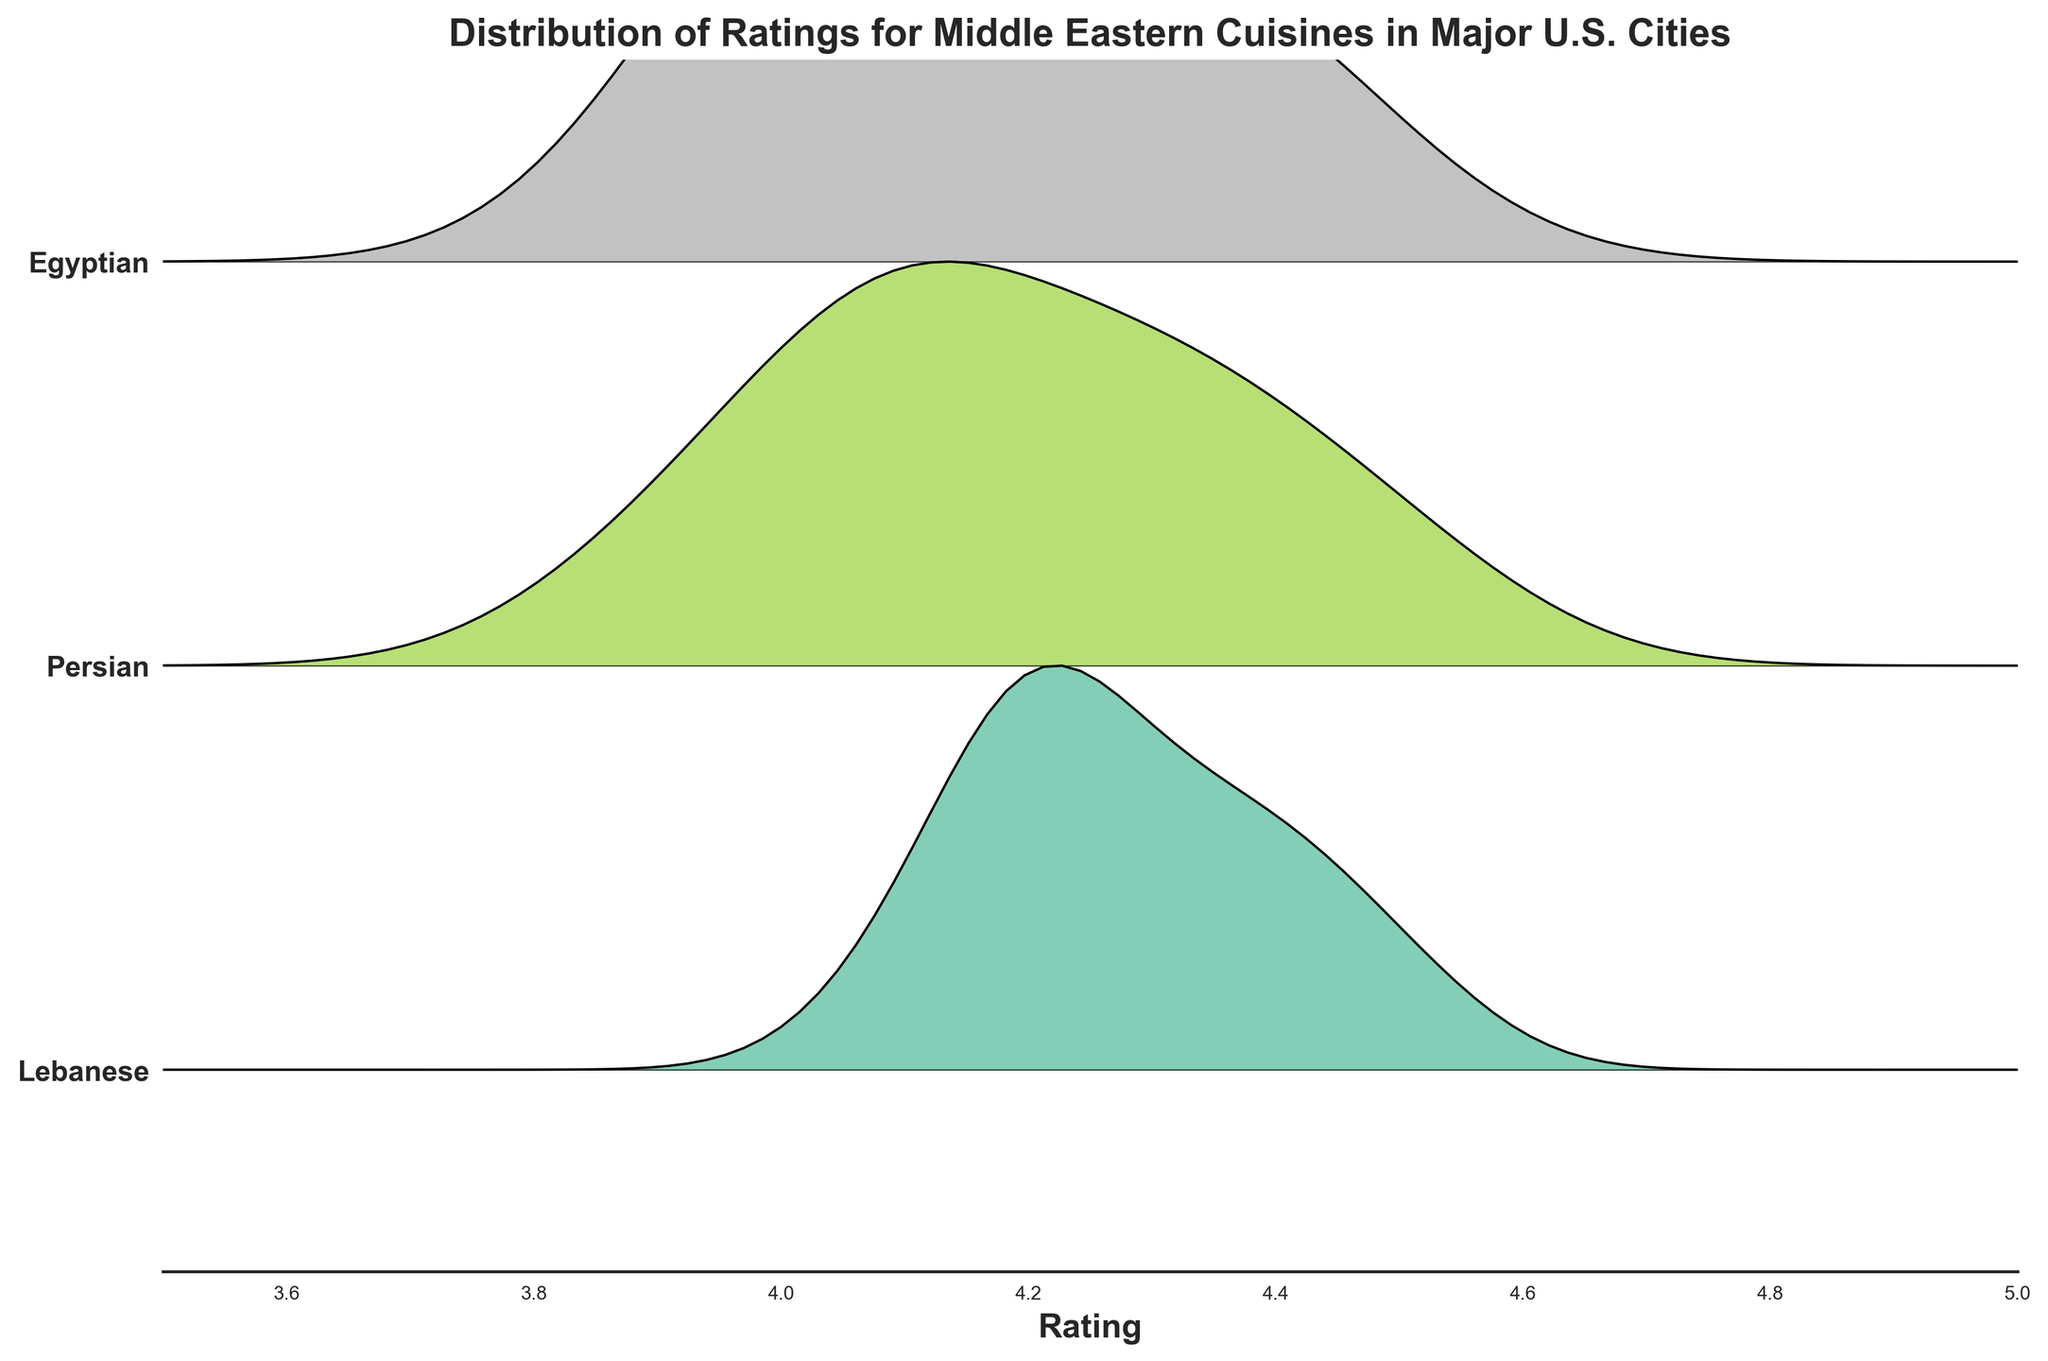What's the title of the figure? The title of a plot typically appears at the top of the figure. In this case, it would describe the main idea or data being visualized.
Answer: Distribution of Ratings for Middle Eastern Cuisines in Major U.S. Cities Which cuisine type has the most skewed rating distribution? Skewed distributions would appear as asymmetrical ridgelines with one peak at one end of the rating scale. Evaluate each cuisine's ridgeline to determine this.
Answer: Egyptian Which city has the highest rated restaurant for Persian cuisine? For Persian cuisine, look at the distributions for each city and identify the highest peak or value on the x-axis (rating scale).
Answer: Los Angeles What is the range of ratings on the x-axis? This can be determined by looking at the x-axis and noting the minimum and maximum values present.
Answer: 3.5 to 5 Among Lebanese, Persian, and Egyptian cuisines, which has the highest average peak height in the ridgeline plot? Compare the average heights of the peaks for the ridgelines associated with Lebanese, Persian, and Egyptian cuisines. The average peak height generally indicates the density of ratings around a central value.
Answer: Lebanese Which cuisine shows the least variation in ratings? Least variation in ratings would be represented by a narrow, tall ridgeline indicating that the ratings are closely clustered together.
Answer: Lebanese Do Persian restaurants in Chicago have higher ratings on average than those in New York? Compare the peak positions (central tendencies) of the Persian cuisine ridgelines for Chicago and New York.
Answer: Yes Which cuisine appears to dominate around the highest rating on the plot? Look for the ridgeline that extends the furthest toward the right side of the x-axis (nearest to 5) and has the highest density in that region.
Answer: Persian How many different cuisine types are displayed in the figure? Count the number of unique cuisine labels on the y-axis.
Answer: Three What is the primary color used for the Lebanese ridgeline? Identify the color corresponding to the ridgeline labeled "Lebanese" on the y-axis.
Answer: This will require visual inspection Is there a clear trend in the central tendency of ratings across the different cuisines? Observe the central points of the ridgelines and determine if there's any visible pattern or similarity among them (e.g., if most cuisines are generally rated high or low).
Answer: Yes, most cuisines have high ratings around 4.2-4.4 